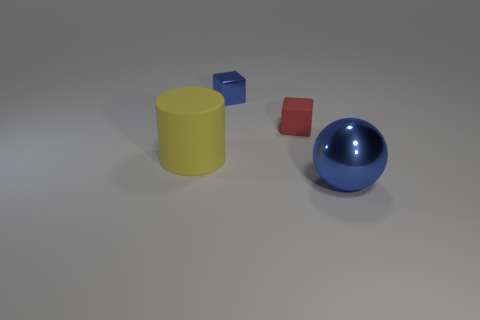What is the material of the other tiny thing that is the same shape as the tiny metal thing?
Give a very brief answer. Rubber. There is a tiny object that is the same color as the ball; what material is it?
Provide a short and direct response. Metal. There is another object that is the same size as the red object; what is its shape?
Offer a terse response. Cube. What number of blue objects are on the left side of the blue metal object to the right of the tiny red matte cube that is to the right of the tiny blue thing?
Provide a succinct answer. 1. Is the number of large blue shiny things to the right of the large rubber cylinder greater than the number of small matte cubes behind the tiny red rubber thing?
Offer a terse response. Yes. What number of other tiny yellow rubber things are the same shape as the tiny rubber thing?
Keep it short and to the point. 0. What number of objects are large objects that are in front of the large yellow matte object or large things that are in front of the yellow cylinder?
Your answer should be compact. 1. What material is the large object on the left side of the big object that is to the right of the cube that is to the right of the tiny blue metal cube?
Your response must be concise. Rubber. There is a metal object that is on the right side of the matte block; is its color the same as the tiny shiny block?
Offer a very short reply. Yes. What is the object that is both on the right side of the small metal thing and behind the matte cylinder made of?
Offer a terse response. Rubber. 